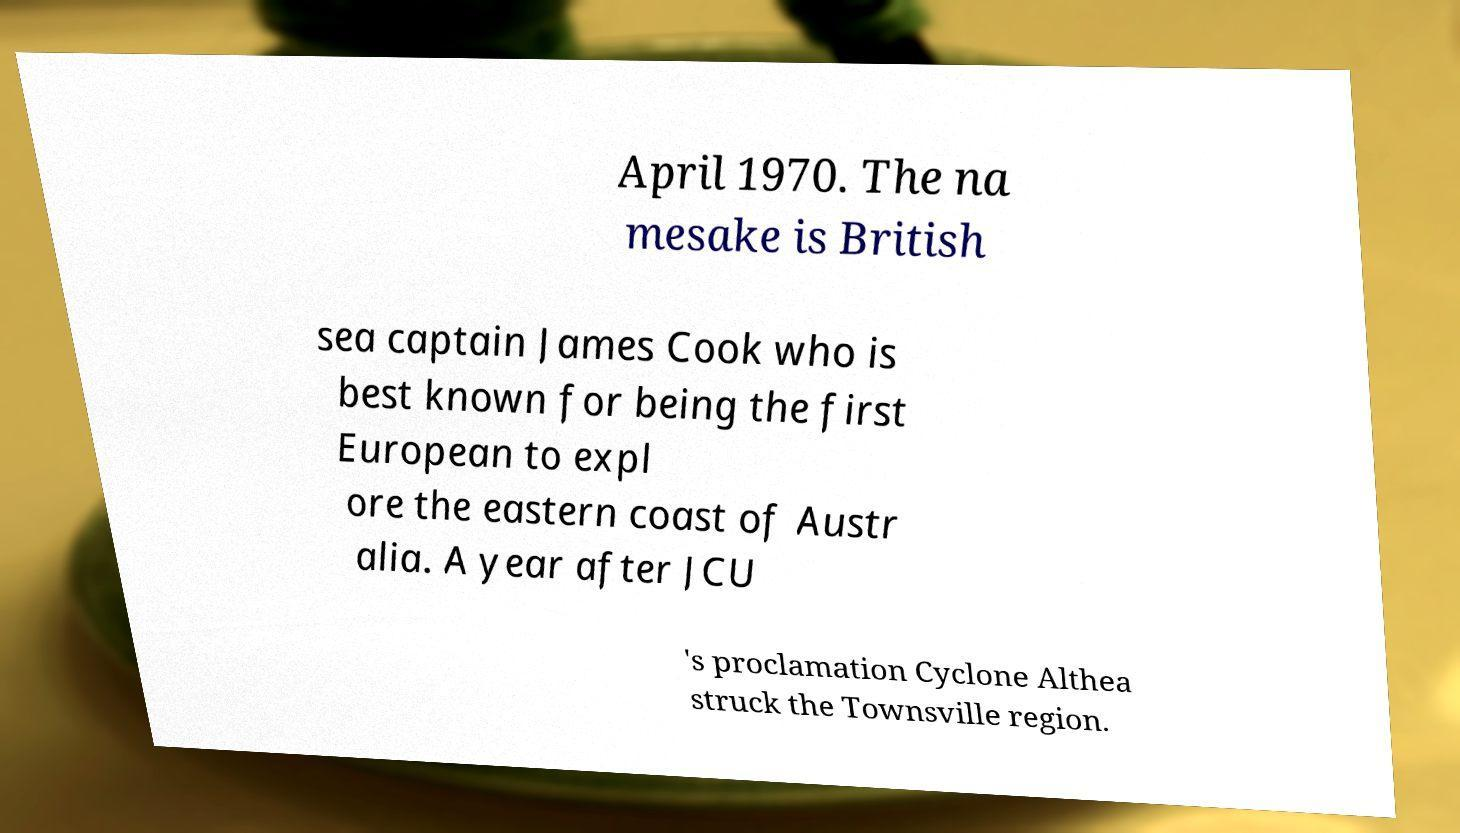For documentation purposes, I need the text within this image transcribed. Could you provide that? April 1970. The na mesake is British sea captain James Cook who is best known for being the first European to expl ore the eastern coast of Austr alia. A year after JCU 's proclamation Cyclone Althea struck the Townsville region. 